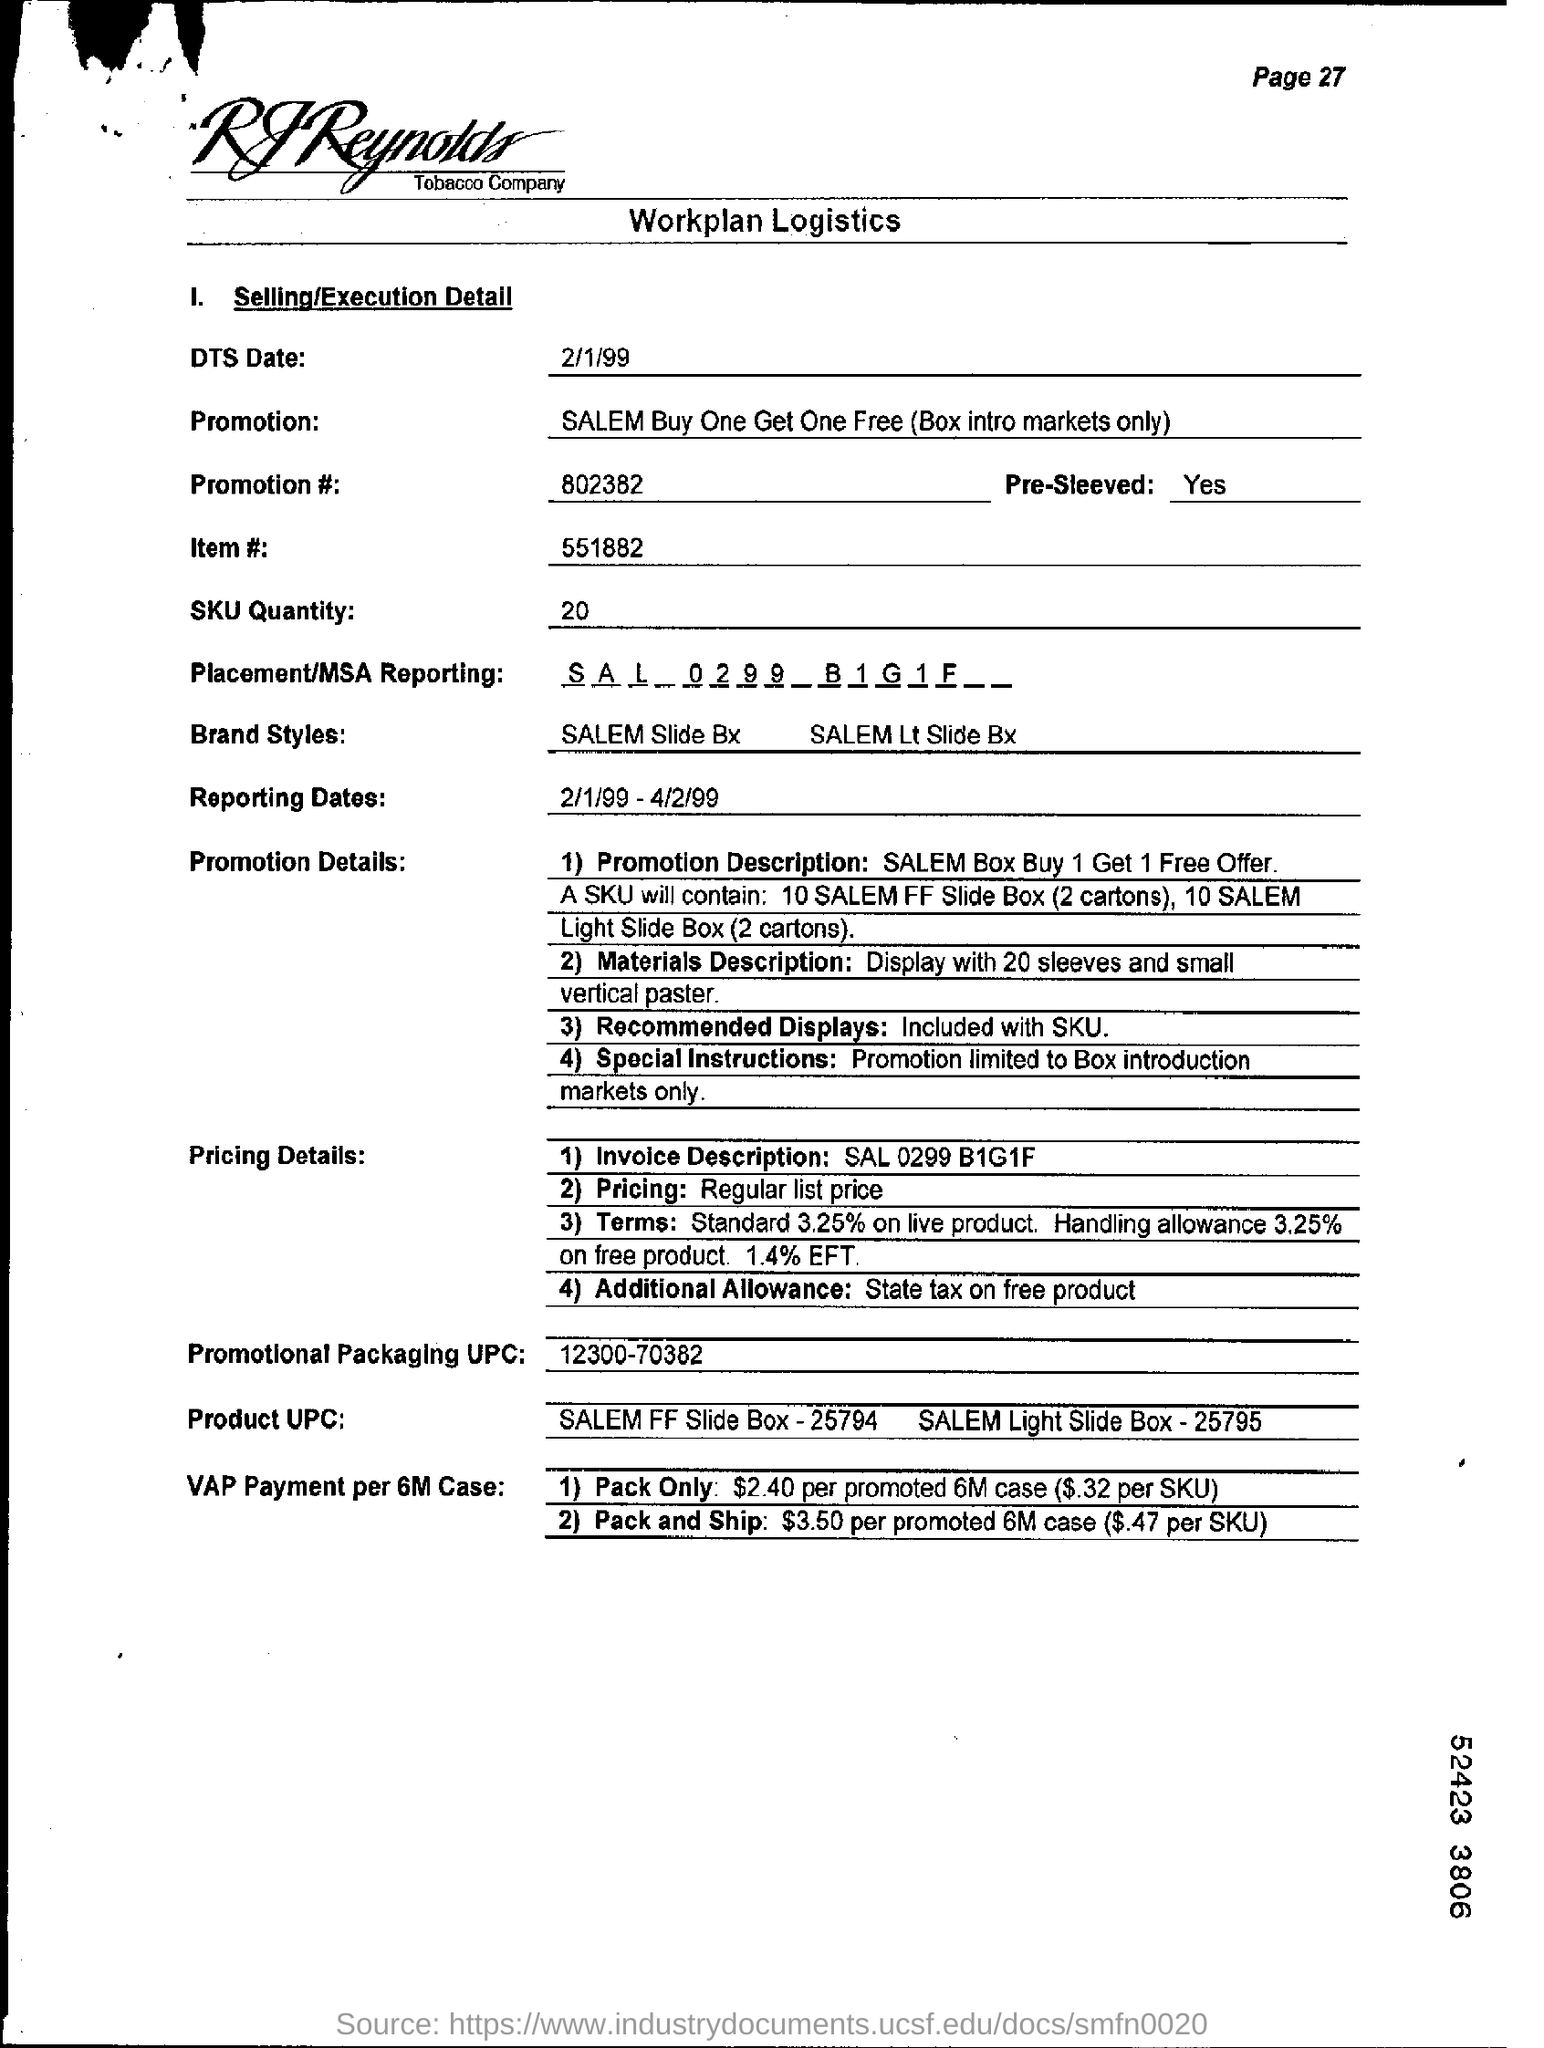Which Company's Workplan Logistics is given here?
Keep it short and to the point. RJ Reynolds Tobacco Company. What is the DTS date mentioned in this document?
Offer a very short reply. 2/1/99. What is the promotion no given in the document?
Ensure brevity in your answer.  802382. What is the item no mentioned in the document?
Your answer should be compact. 551882. What is the SKU Quantity as per the document?
Your response must be concise. 20. What is the Promotional Packaging UPC mentioned in the document?
Provide a short and direct response. 12300-70382. What are the reporting dates given in the document?
Offer a terse response. 2/1/99 - 4/2/99. 